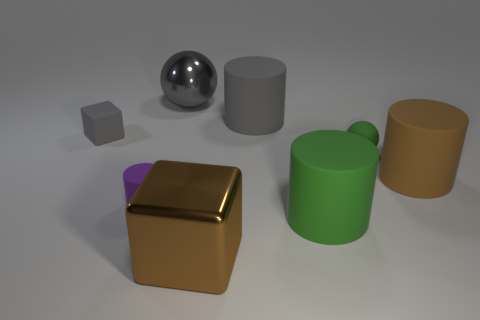There is a brown matte object in front of the small gray cube; does it have the same shape as the brown metallic object?
Keep it short and to the point. No. There is a brown cylinder that is the same material as the purple cylinder; what size is it?
Keep it short and to the point. Large. How many things are big metallic things that are behind the rubber sphere or large objects on the right side of the green cylinder?
Keep it short and to the point. 2. Are there the same number of spheres that are behind the gray sphere and brown cylinders in front of the small green sphere?
Ensure brevity in your answer.  No. The tiny rubber object right of the green cylinder is what color?
Provide a short and direct response. Green. Does the small rubber cube have the same color as the big rubber object that is in front of the brown rubber cylinder?
Provide a short and direct response. No. Are there fewer cylinders than tiny rubber balls?
Provide a short and direct response. No. There is a big rubber cylinder that is in front of the small purple matte thing; is it the same color as the small ball?
Provide a succinct answer. Yes. How many brown blocks have the same size as the gray ball?
Provide a short and direct response. 1. Is there a matte thing that has the same color as the big sphere?
Offer a very short reply. Yes. 